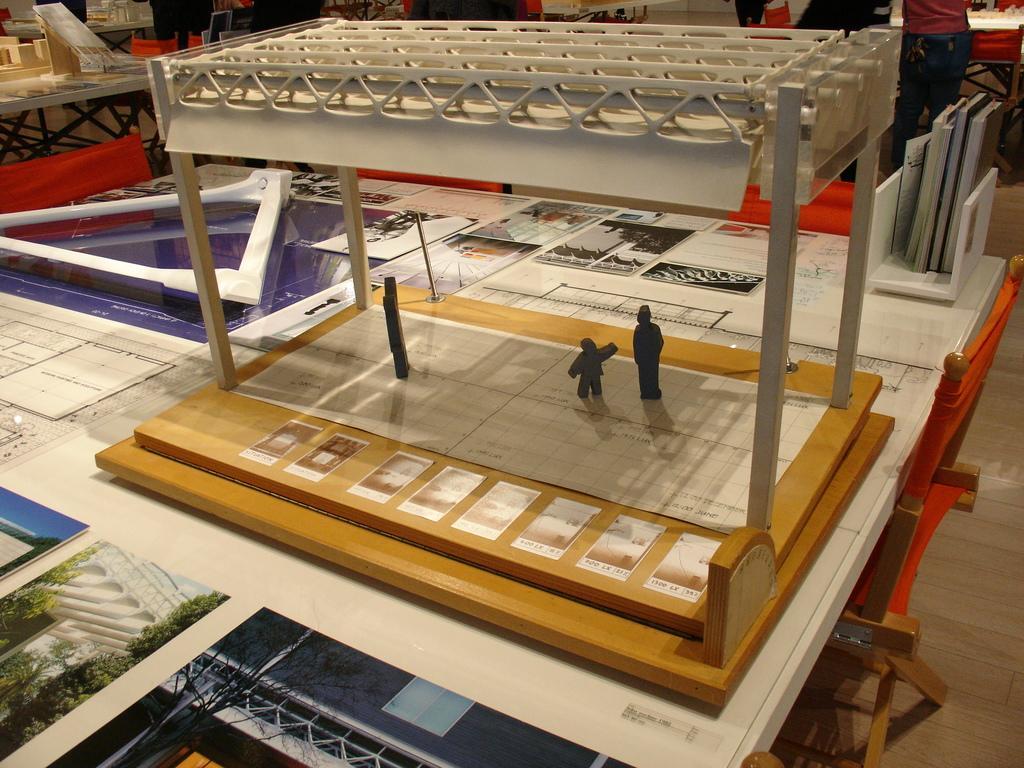Describe this image in one or two sentences. This picture seems to be clicked inside the room. In the center we can see a table on the top of which posters containing some pictures of some objects and the pictures of trees and we can see the books, toys and some objects are placed. In the background there are many number of objects placed on the top of the tables and we can see the the persons and many other objects. 